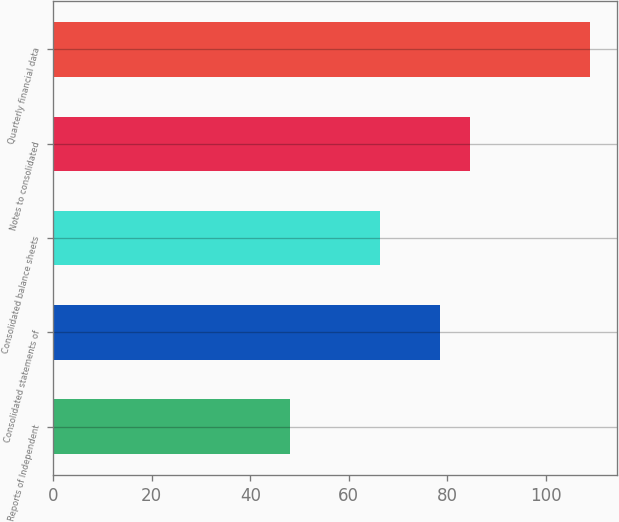<chart> <loc_0><loc_0><loc_500><loc_500><bar_chart><fcel>Reports of Independent<fcel>Consolidated statements of<fcel>Consolidated balance sheets<fcel>Notes to consolidated<fcel>Quarterly financial data<nl><fcel>48<fcel>78.5<fcel>66.3<fcel>84.6<fcel>109<nl></chart> 